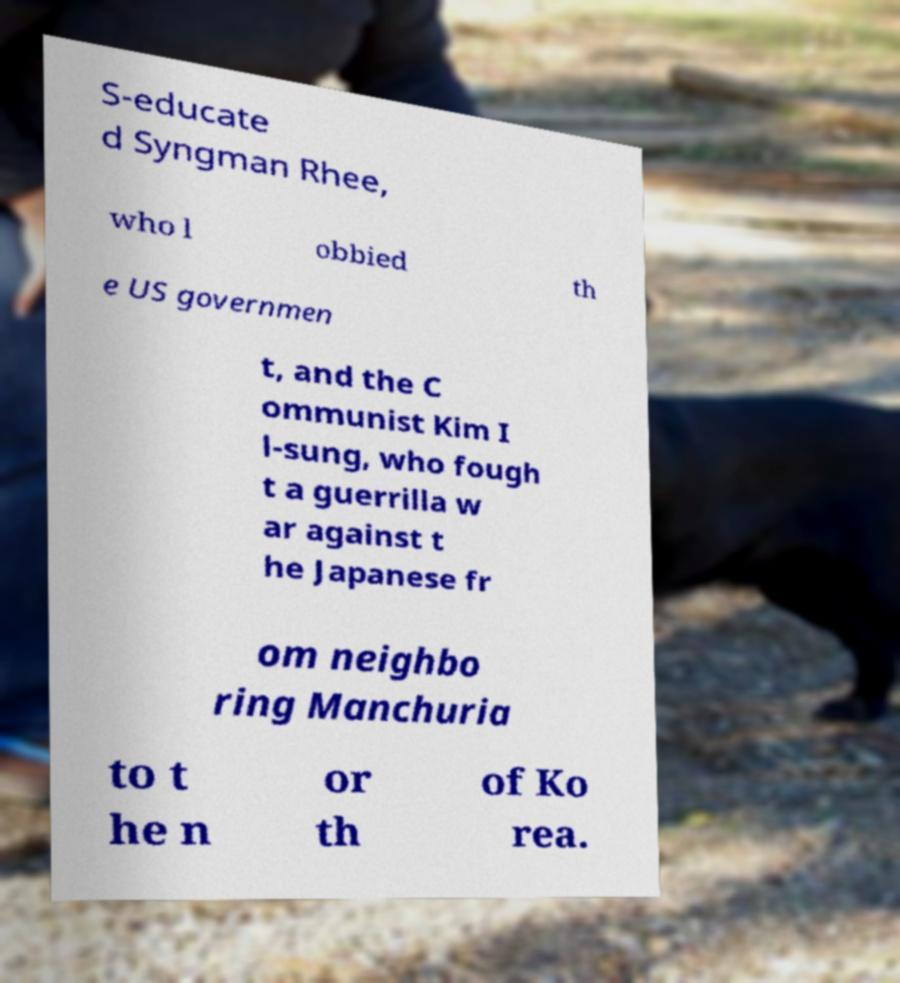Please read and relay the text visible in this image. What does it say? S-educate d Syngman Rhee, who l obbied th e US governmen t, and the C ommunist Kim I l-sung, who fough t a guerrilla w ar against t he Japanese fr om neighbo ring Manchuria to t he n or th of Ko rea. 